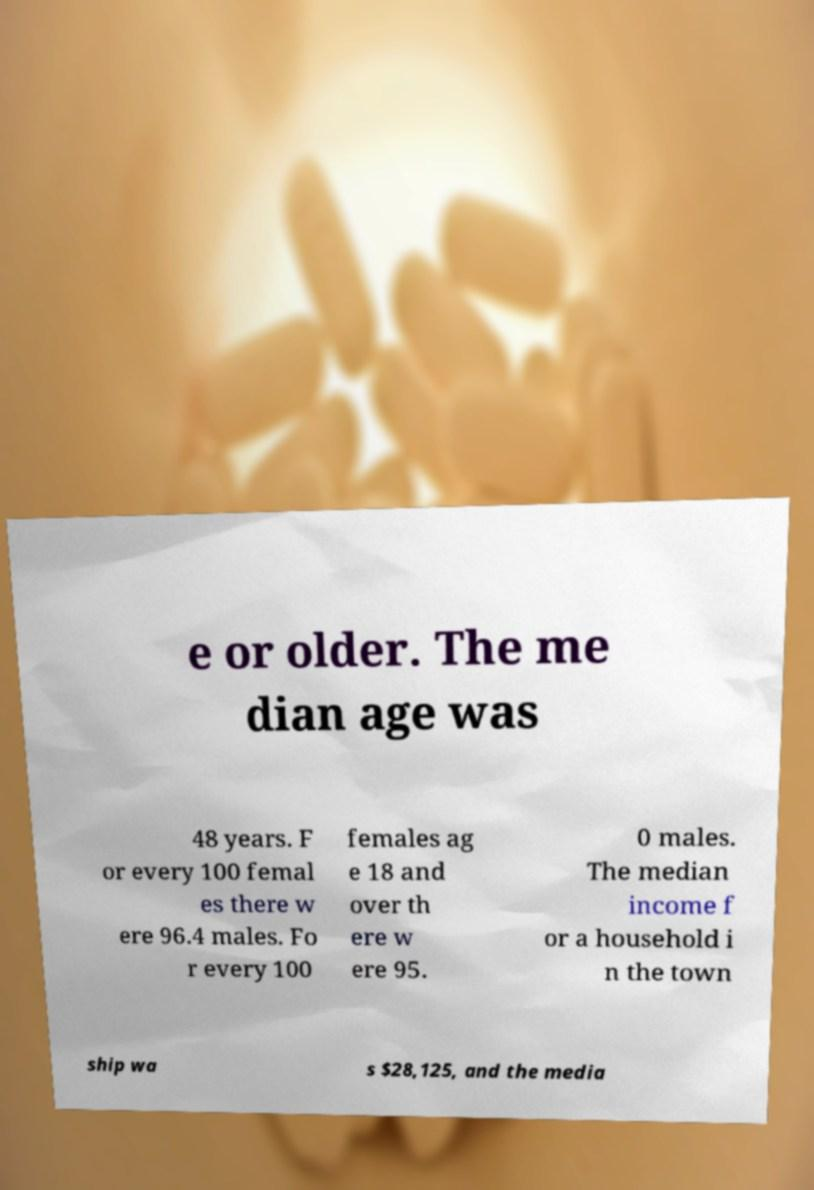Could you assist in decoding the text presented in this image and type it out clearly? e or older. The me dian age was 48 years. F or every 100 femal es there w ere 96.4 males. Fo r every 100 females ag e 18 and over th ere w ere 95. 0 males. The median income f or a household i n the town ship wa s $28,125, and the media 